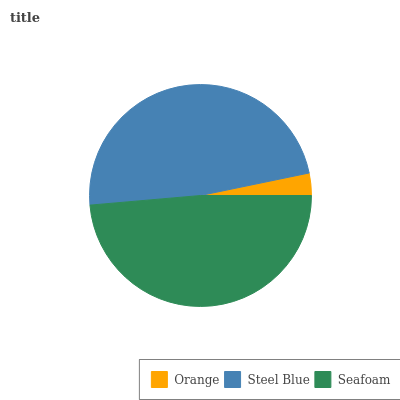Is Orange the minimum?
Answer yes or no. Yes. Is Seafoam the maximum?
Answer yes or no. Yes. Is Steel Blue the minimum?
Answer yes or no. No. Is Steel Blue the maximum?
Answer yes or no. No. Is Steel Blue greater than Orange?
Answer yes or no. Yes. Is Orange less than Steel Blue?
Answer yes or no. Yes. Is Orange greater than Steel Blue?
Answer yes or no. No. Is Steel Blue less than Orange?
Answer yes or no. No. Is Steel Blue the high median?
Answer yes or no. Yes. Is Steel Blue the low median?
Answer yes or no. Yes. Is Orange the high median?
Answer yes or no. No. Is Orange the low median?
Answer yes or no. No. 